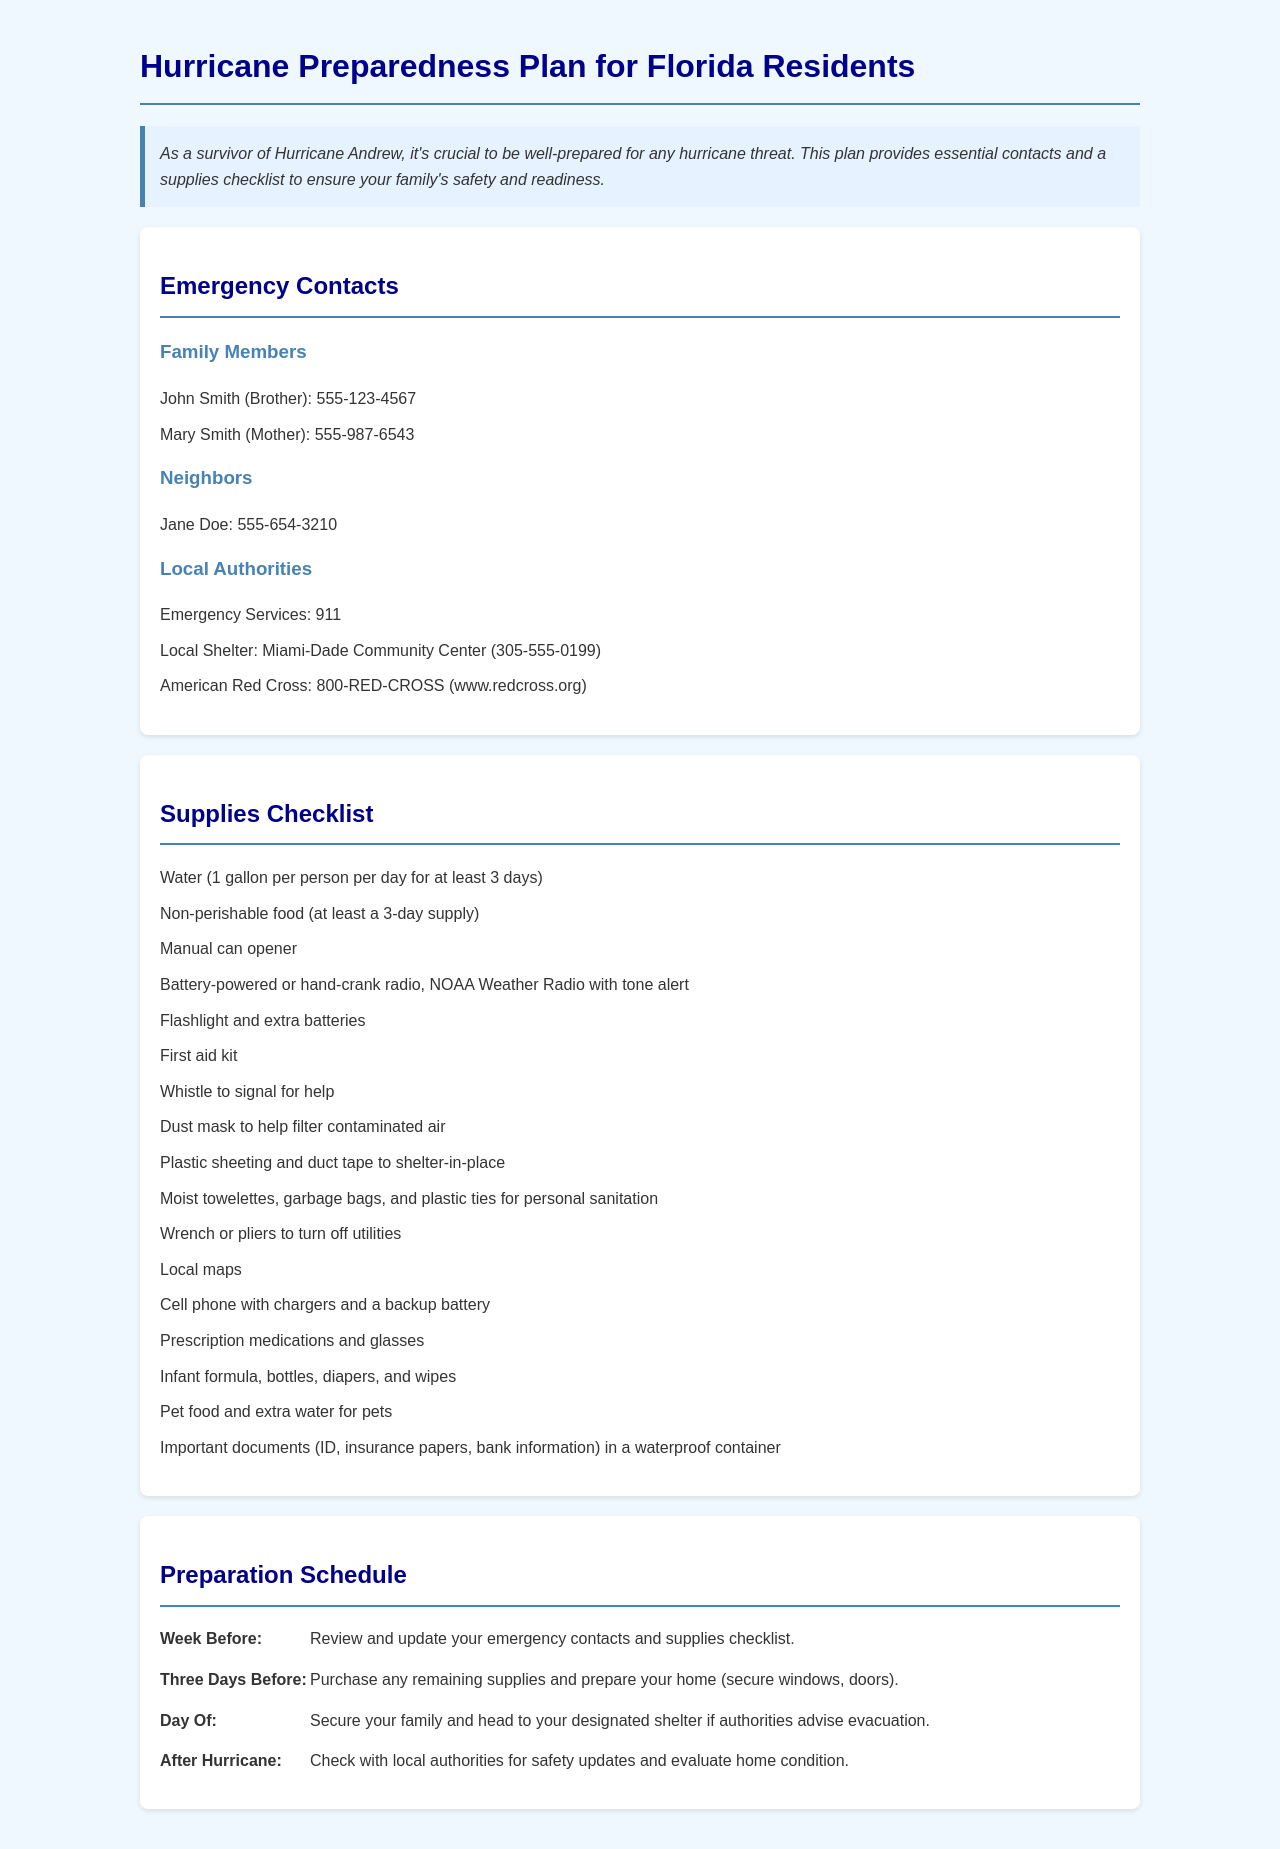what is the emergency contact number for American Red Cross? The document lists the emergency contact number for American Red Cross as 800-RED-CROSS.
Answer: 800-RED-CROSS who is listed as a neighbor in the emergency contacts? The document includes Jane Doe as a neighbor in the emergency contacts section.
Answer: Jane Doe how many gallons of water should each person have? The document states each person should have 1 gallon of water per day for at least 3 days.
Answer: 1 gallon what should you do three days before a hurricane? The document indicates you should purchase any remaining supplies and prepare your home (secure windows, doors).
Answer: Purchase remaining supplies what is the first item listed on the supplies checklist? The first item on the supplies checklist is water for each person.
Answer: Water what should you do after the hurricane? The document advises checking with local authorities for safety updates and evaluating home condition.
Answer: Check with local authorities how many family members are listed in the emergency contacts? The document lists two family members in the emergency contacts section.
Answer: Two what type of document is this prepared for? The document is a hurricane preparedness plan specifically for Florida residents.
Answer: Hurricane preparedness plan 